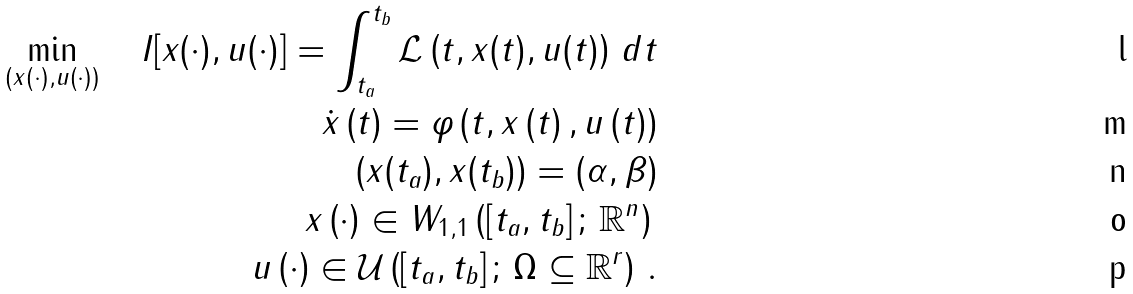Convert formula to latex. <formula><loc_0><loc_0><loc_500><loc_500>\min _ { \left ( x ( \cdot ) , u ( \cdot ) \right ) } \quad I [ x ( \cdot ) , u ( \cdot ) ] = \int _ { t _ { a } } ^ { t _ { b } } \mathcal { L } \left ( t , x ( t ) , u ( t ) \right ) \, d t \\ \dot { x } \left ( t \right ) = \varphi \left ( t , x \left ( t \right ) , u \left ( t \right ) \right ) \\ \left ( x ( t _ { a } ) , x ( t _ { b } ) \right ) = ( \alpha , \beta ) \\ x \left ( \cdot \right ) \in W _ { 1 , 1 } \left ( \left [ t _ { a } , t _ { b } \right ] ; \, \mathbb { R } ^ { n } \right ) \, \\ u \left ( \cdot \right ) \in \mathcal { U } \left ( \left [ t _ { a } , t _ { b } \right ] ; \, \Omega \subseteq \mathbb { R } ^ { r } \right ) \, .</formula> 